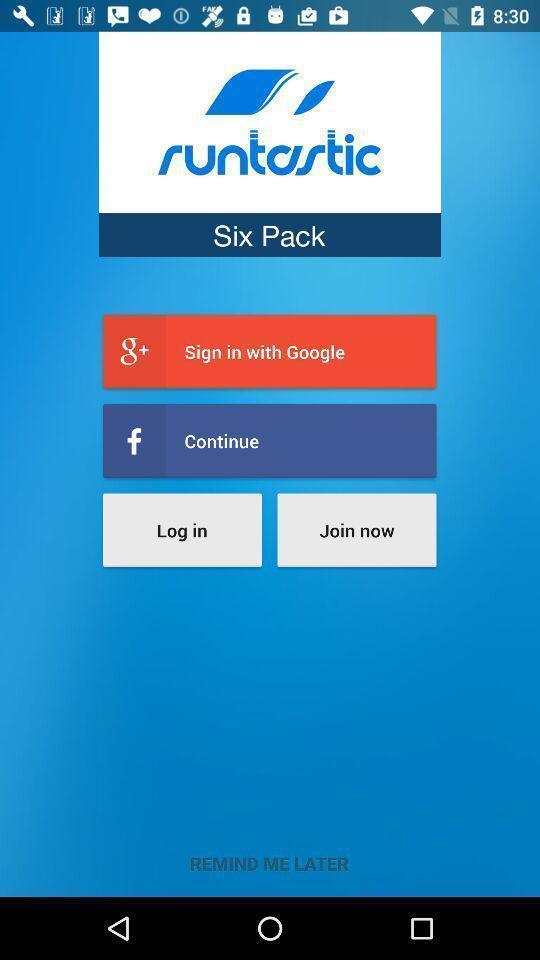Tell me what you see in this picture. Sign in page displayed. 